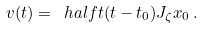Convert formula to latex. <formula><loc_0><loc_0><loc_500><loc_500>v ( t ) = \ h a l f t ( t - t _ { 0 } ) J _ { \zeta } x _ { 0 } \, .</formula> 